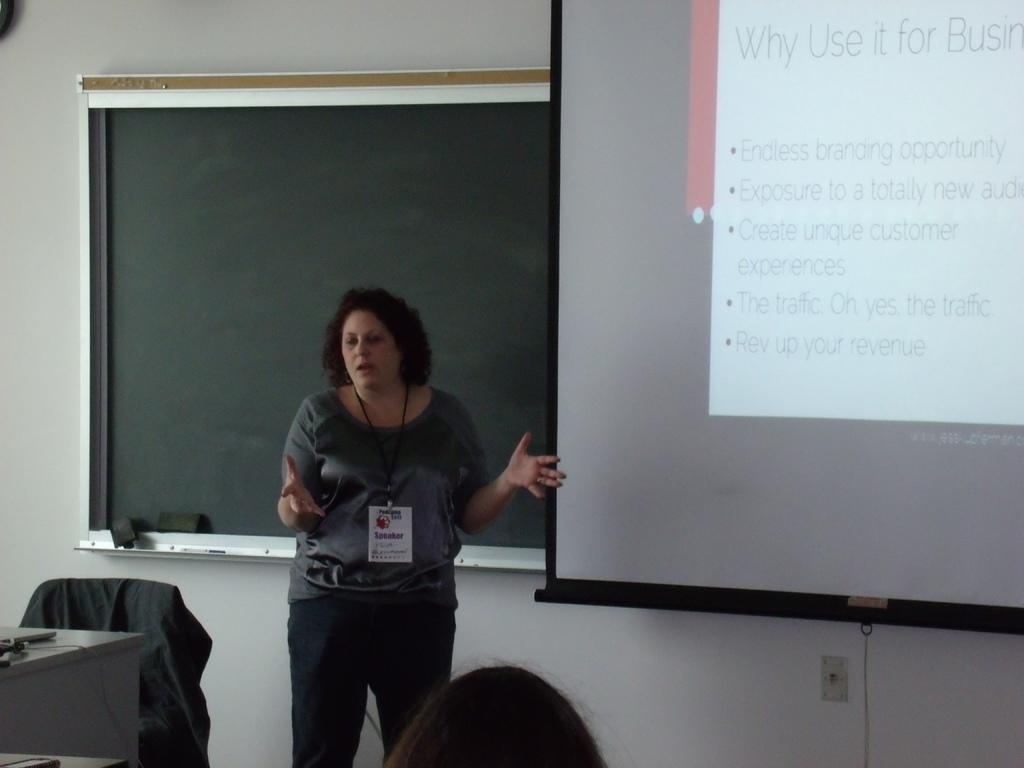In one or two sentences, can you explain what this image depicts? In the picture we can see a woman standing and explaining something to the people who are in front of her and behind her we can see a black color board and beside it, we can see a screen with some information on it and beside her we can see a table and chair and she is wearing an ID card. 